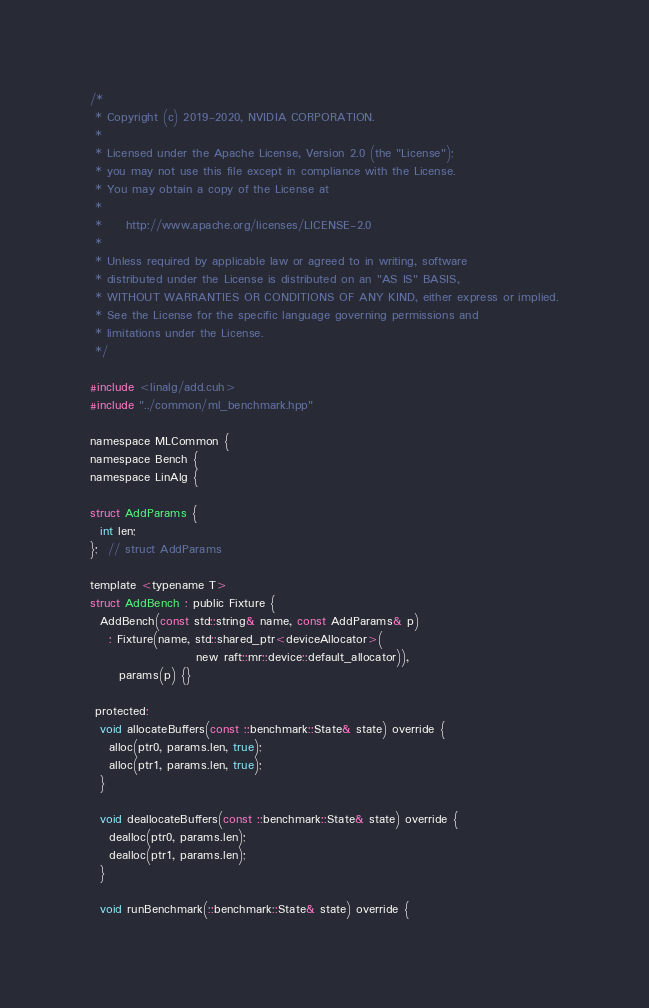<code> <loc_0><loc_0><loc_500><loc_500><_Cuda_>/*
 * Copyright (c) 2019-2020, NVIDIA CORPORATION.
 *
 * Licensed under the Apache License, Version 2.0 (the "License");
 * you may not use this file except in compliance with the License.
 * You may obtain a copy of the License at
 *
 *     http://www.apache.org/licenses/LICENSE-2.0
 *
 * Unless required by applicable law or agreed to in writing, software
 * distributed under the License is distributed on an "AS IS" BASIS,
 * WITHOUT WARRANTIES OR CONDITIONS OF ANY KIND, either express or implied.
 * See the License for the specific language governing permissions and
 * limitations under the License.
 */

#include <linalg/add.cuh>
#include "../common/ml_benchmark.hpp"

namespace MLCommon {
namespace Bench {
namespace LinAlg {

struct AddParams {
  int len;
};  // struct AddParams

template <typename T>
struct AddBench : public Fixture {
  AddBench(const std::string& name, const AddParams& p)
    : Fixture(name, std::shared_ptr<deviceAllocator>(
                      new raft::mr::device::default_allocator)),
      params(p) {}

 protected:
  void allocateBuffers(const ::benchmark::State& state) override {
    alloc(ptr0, params.len, true);
    alloc(ptr1, params.len, true);
  }

  void deallocateBuffers(const ::benchmark::State& state) override {
    dealloc(ptr0, params.len);
    dealloc(ptr1, params.len);
  }

  void runBenchmark(::benchmark::State& state) override {</code> 